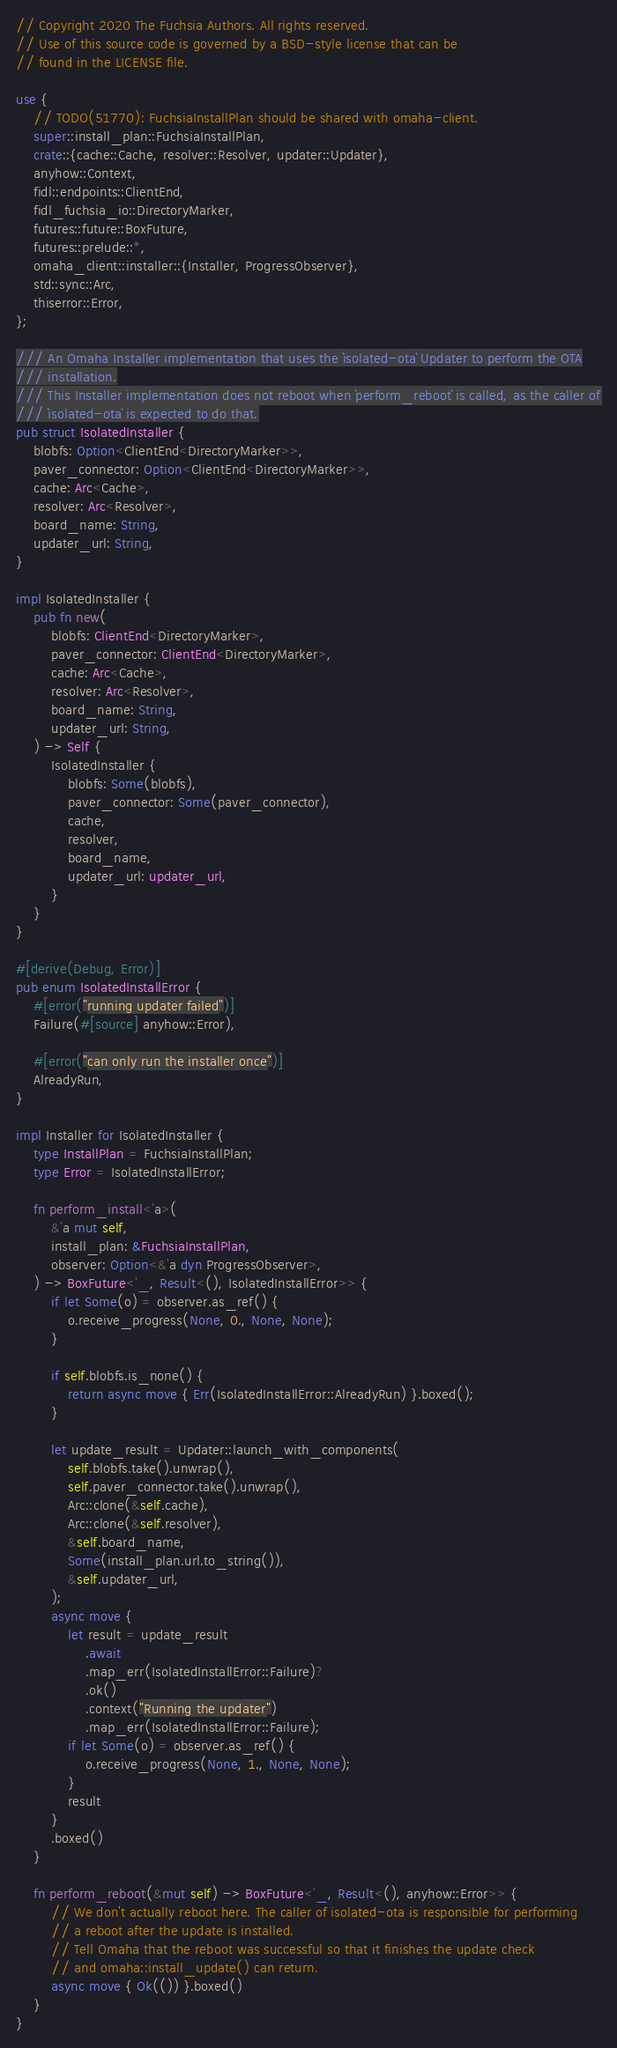Convert code to text. <code><loc_0><loc_0><loc_500><loc_500><_Rust_>// Copyright 2020 The Fuchsia Authors. All rights reserved.
// Use of this source code is governed by a BSD-style license that can be
// found in the LICENSE file.

use {
    // TODO(51770): FuchsiaInstallPlan should be shared with omaha-client.
    super::install_plan::FuchsiaInstallPlan,
    crate::{cache::Cache, resolver::Resolver, updater::Updater},
    anyhow::Context,
    fidl::endpoints::ClientEnd,
    fidl_fuchsia_io::DirectoryMarker,
    futures::future::BoxFuture,
    futures::prelude::*,
    omaha_client::installer::{Installer, ProgressObserver},
    std::sync::Arc,
    thiserror::Error,
};

/// An Omaha Installer implementation that uses the `isolated-ota` Updater to perform the OTA
/// installation.
/// This Installer implementation does not reboot when `perform_reboot` is called, as the caller of
/// `isolated-ota` is expected to do that.
pub struct IsolatedInstaller {
    blobfs: Option<ClientEnd<DirectoryMarker>>,
    paver_connector: Option<ClientEnd<DirectoryMarker>>,
    cache: Arc<Cache>,
    resolver: Arc<Resolver>,
    board_name: String,
    updater_url: String,
}

impl IsolatedInstaller {
    pub fn new(
        blobfs: ClientEnd<DirectoryMarker>,
        paver_connector: ClientEnd<DirectoryMarker>,
        cache: Arc<Cache>,
        resolver: Arc<Resolver>,
        board_name: String,
        updater_url: String,
    ) -> Self {
        IsolatedInstaller {
            blobfs: Some(blobfs),
            paver_connector: Some(paver_connector),
            cache,
            resolver,
            board_name,
            updater_url: updater_url,
        }
    }
}

#[derive(Debug, Error)]
pub enum IsolatedInstallError {
    #[error("running updater failed")]
    Failure(#[source] anyhow::Error),

    #[error("can only run the installer once")]
    AlreadyRun,
}

impl Installer for IsolatedInstaller {
    type InstallPlan = FuchsiaInstallPlan;
    type Error = IsolatedInstallError;

    fn perform_install<'a>(
        &'a mut self,
        install_plan: &FuchsiaInstallPlan,
        observer: Option<&'a dyn ProgressObserver>,
    ) -> BoxFuture<'_, Result<(), IsolatedInstallError>> {
        if let Some(o) = observer.as_ref() {
            o.receive_progress(None, 0., None, None);
        }

        if self.blobfs.is_none() {
            return async move { Err(IsolatedInstallError::AlreadyRun) }.boxed();
        }

        let update_result = Updater::launch_with_components(
            self.blobfs.take().unwrap(),
            self.paver_connector.take().unwrap(),
            Arc::clone(&self.cache),
            Arc::clone(&self.resolver),
            &self.board_name,
            Some(install_plan.url.to_string()),
            &self.updater_url,
        );
        async move {
            let result = update_result
                .await
                .map_err(IsolatedInstallError::Failure)?
                .ok()
                .context("Running the updater")
                .map_err(IsolatedInstallError::Failure);
            if let Some(o) = observer.as_ref() {
                o.receive_progress(None, 1., None, None);
            }
            result
        }
        .boxed()
    }

    fn perform_reboot(&mut self) -> BoxFuture<'_, Result<(), anyhow::Error>> {
        // We don't actually reboot here. The caller of isolated-ota is responsible for performing
        // a reboot after the update is installed.
        // Tell Omaha that the reboot was successful so that it finishes the update check
        // and omaha::install_update() can return.
        async move { Ok(()) }.boxed()
    }
}
</code> 